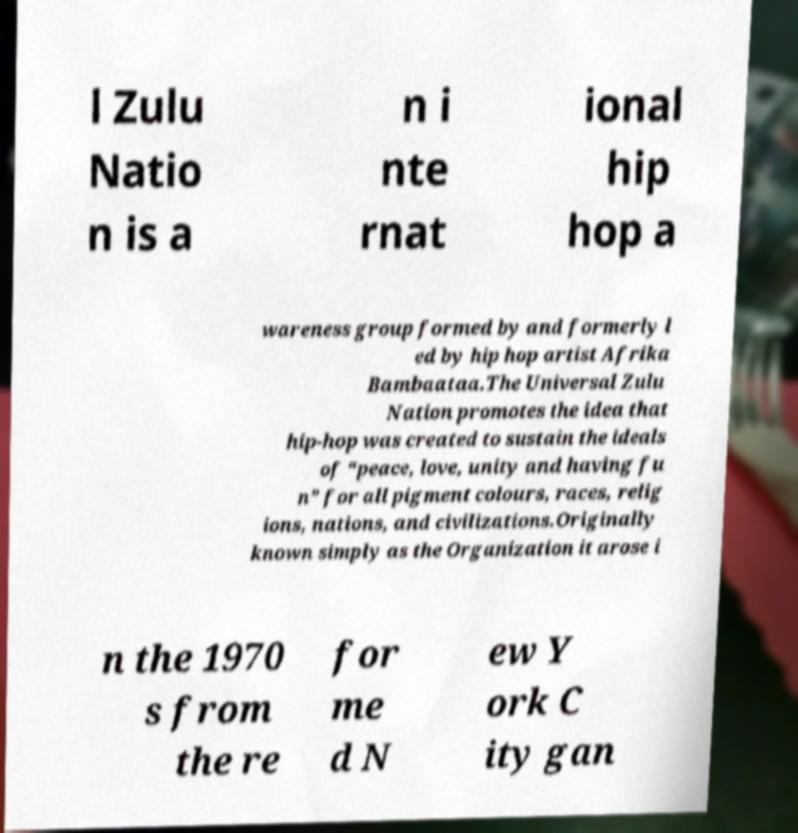There's text embedded in this image that I need extracted. Can you transcribe it verbatim? l Zulu Natio n is a n i nte rnat ional hip hop a wareness group formed by and formerly l ed by hip hop artist Afrika Bambaataa.The Universal Zulu Nation promotes the idea that hip-hop was created to sustain the ideals of “peace, love, unity and having fu n” for all pigment colours, races, relig ions, nations, and civilizations.Originally known simply as the Organization it arose i n the 1970 s from the re for me d N ew Y ork C ity gan 